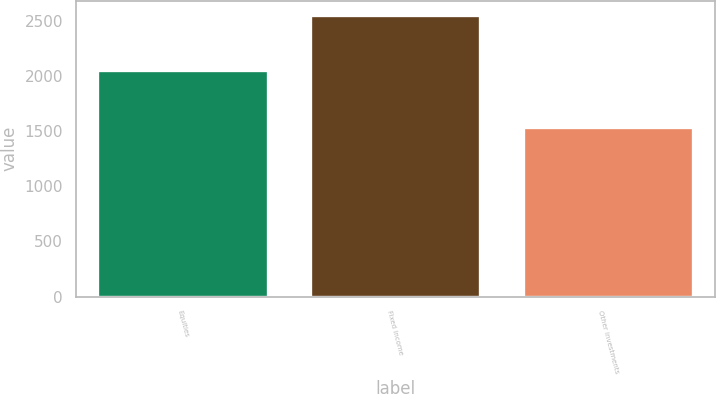Convert chart. <chart><loc_0><loc_0><loc_500><loc_500><bar_chart><fcel>Equities<fcel>Fixed income<fcel>Other investments<nl><fcel>2055<fcel>2555<fcel>1535<nl></chart> 